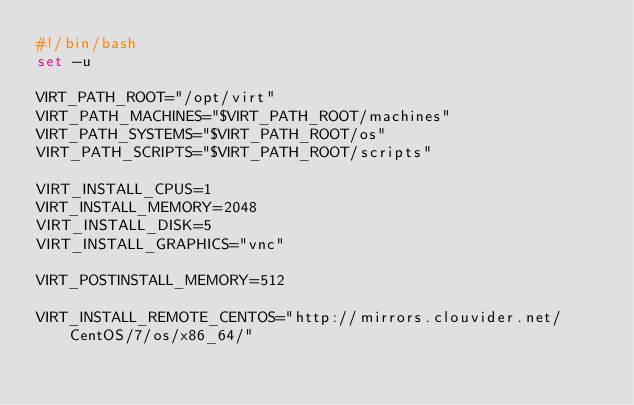<code> <loc_0><loc_0><loc_500><loc_500><_Bash_>#!/bin/bash
set -u

VIRT_PATH_ROOT="/opt/virt"
VIRT_PATH_MACHINES="$VIRT_PATH_ROOT/machines"
VIRT_PATH_SYSTEMS="$VIRT_PATH_ROOT/os"
VIRT_PATH_SCRIPTS="$VIRT_PATH_ROOT/scripts"

VIRT_INSTALL_CPUS=1
VIRT_INSTALL_MEMORY=2048
VIRT_INSTALL_DISK=5
VIRT_INSTALL_GRAPHICS="vnc"

VIRT_POSTINSTALL_MEMORY=512

VIRT_INSTALL_REMOTE_CENTOS="http://mirrors.clouvider.net/CentOS/7/os/x86_64/"
</code> 